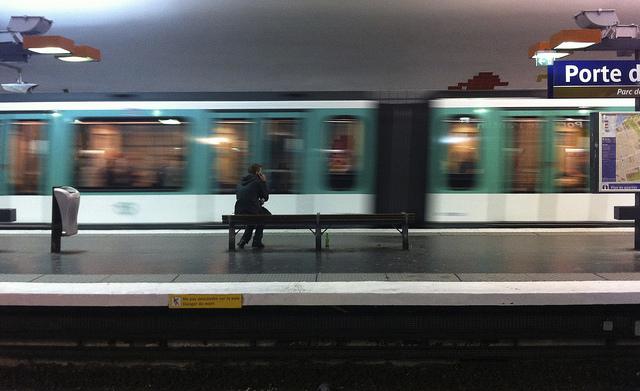What color is the bench?
Write a very short answer. Black. How many people are sitting on the bench?
Be succinct. 1. Is the train moving?
Write a very short answer. Yes. What kind of train is this?
Short answer required. Subway. 